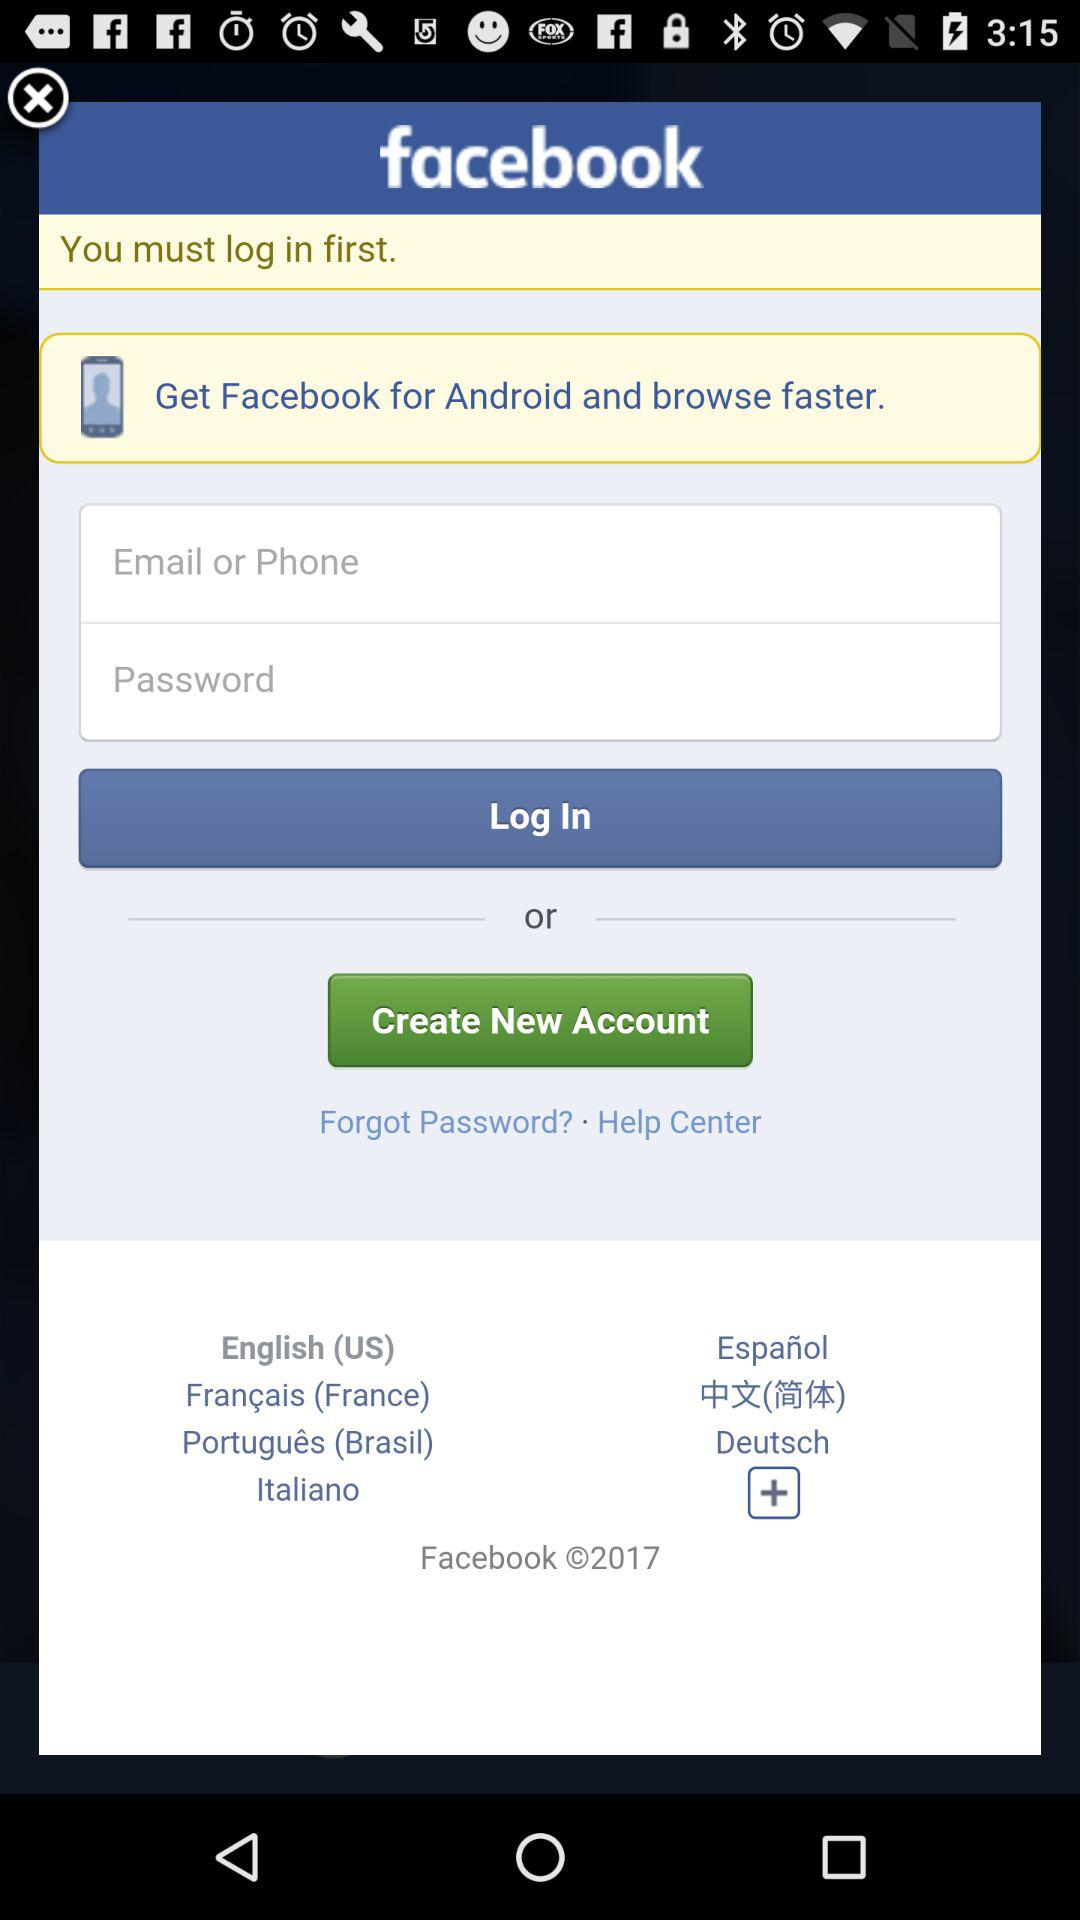What is the copyright year? The copyright year is 2017. 